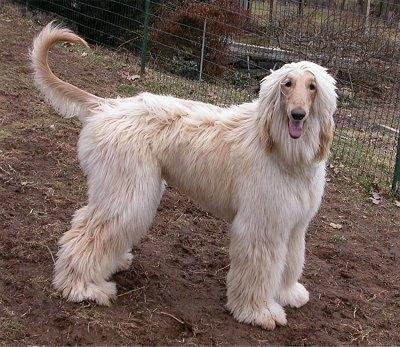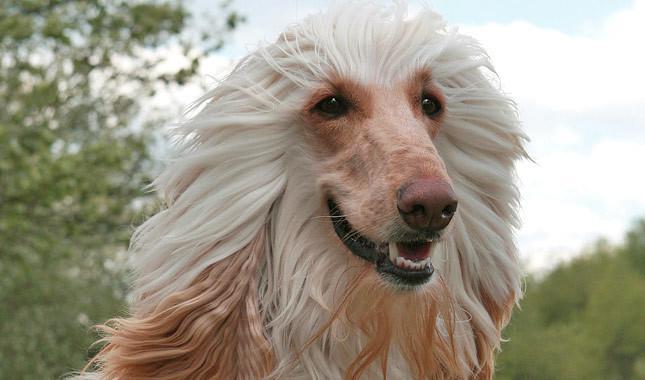The first image is the image on the left, the second image is the image on the right. Given the left and right images, does the statement "One image is a standing dog and one is a dog's head." hold true? Answer yes or no. Yes. The first image is the image on the left, the second image is the image on the right. Evaluate the accuracy of this statement regarding the images: "There is a headshot of a long haired dog.". Is it true? Answer yes or no. Yes. 